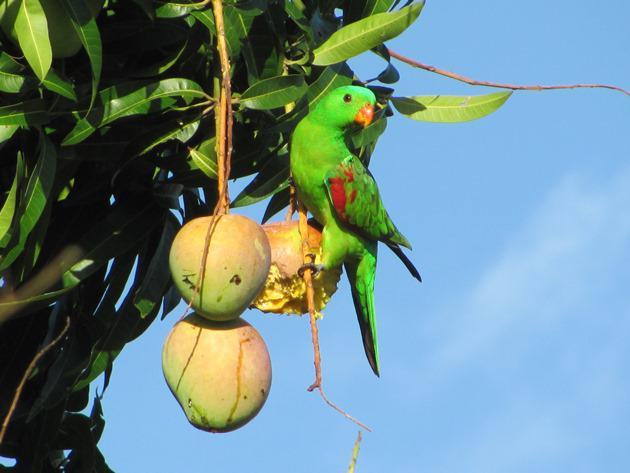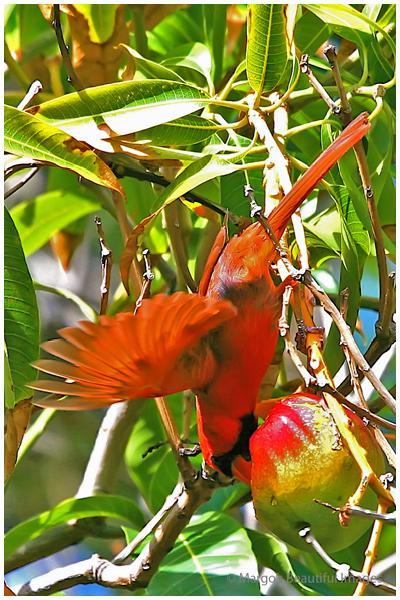The first image is the image on the left, the second image is the image on the right. For the images shown, is this caption "The right image shows a single toucan that has an orange beak and is upside down." true? Answer yes or no. Yes. 